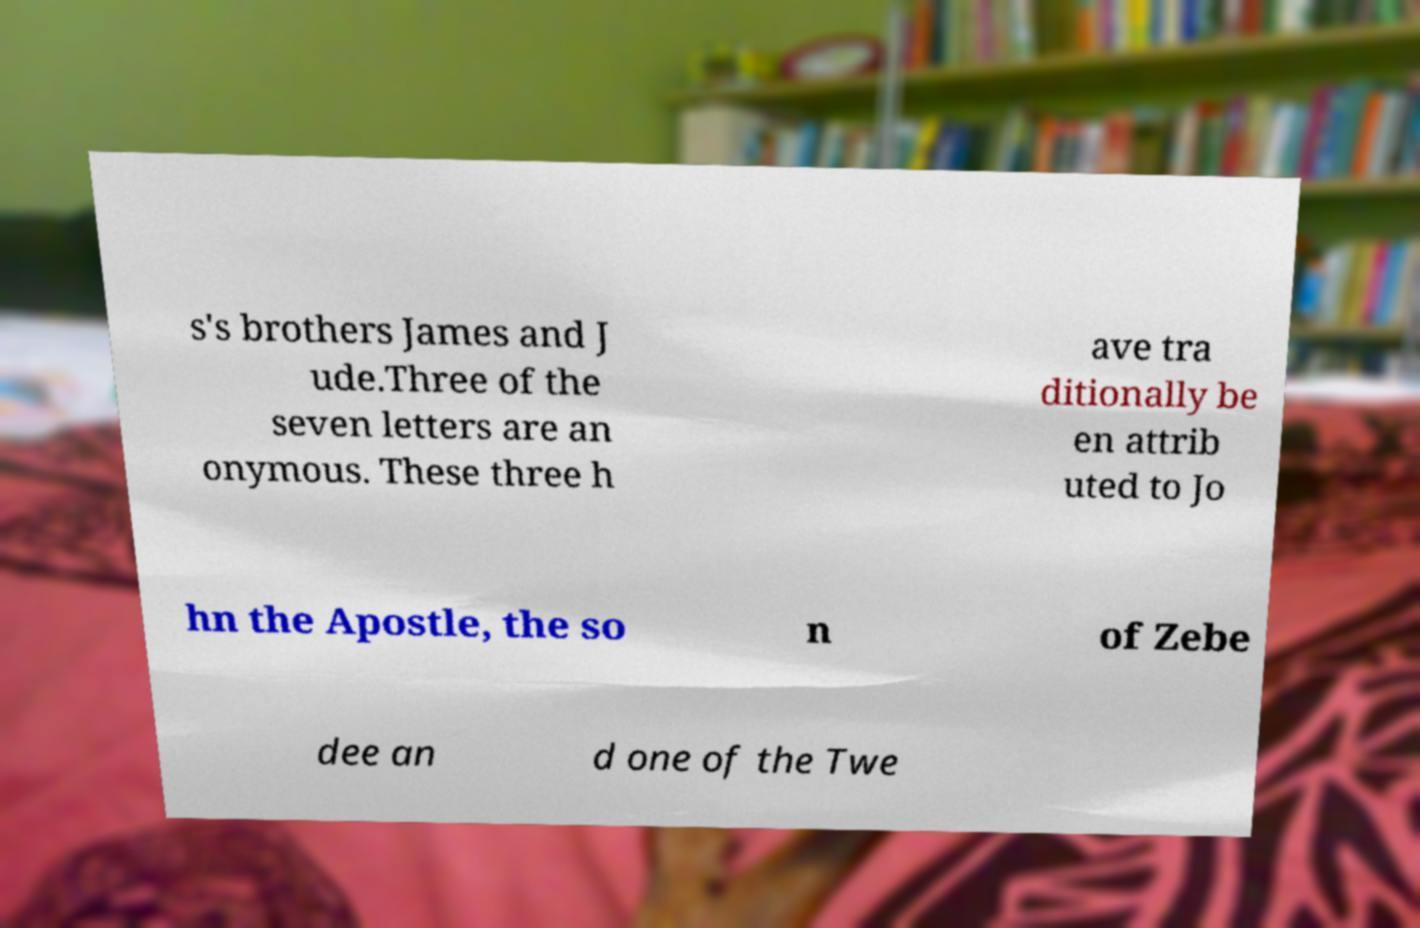Please identify and transcribe the text found in this image. s's brothers James and J ude.Three of the seven letters are an onymous. These three h ave tra ditionally be en attrib uted to Jo hn the Apostle, the so n of Zebe dee an d one of the Twe 